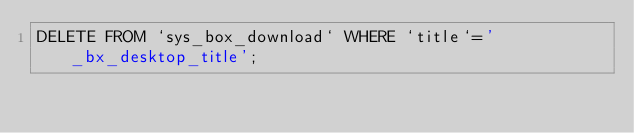Convert code to text. <code><loc_0><loc_0><loc_500><loc_500><_SQL_>DELETE FROM `sys_box_download` WHERE `title`='_bx_desktop_title';</code> 